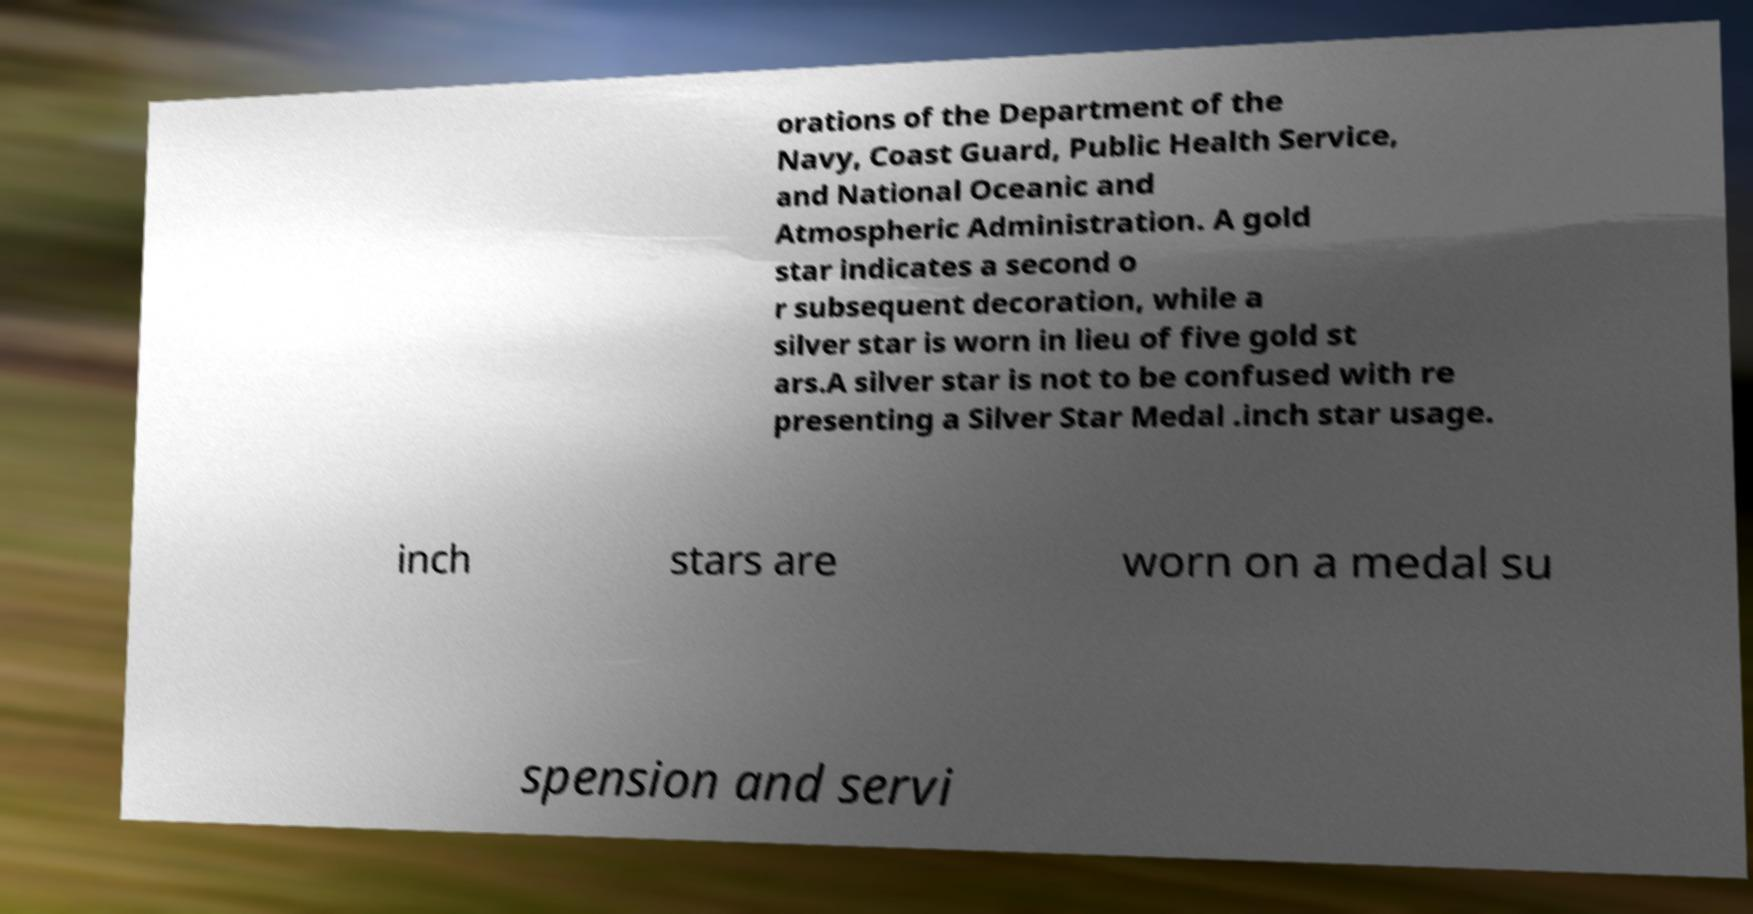There's text embedded in this image that I need extracted. Can you transcribe it verbatim? orations of the Department of the Navy, Coast Guard, Public Health Service, and National Oceanic and Atmospheric Administration. A gold star indicates a second o r subsequent decoration, while a silver star is worn in lieu of five gold st ars.A silver star is not to be confused with re presenting a Silver Star Medal .inch star usage. inch stars are worn on a medal su spension and servi 